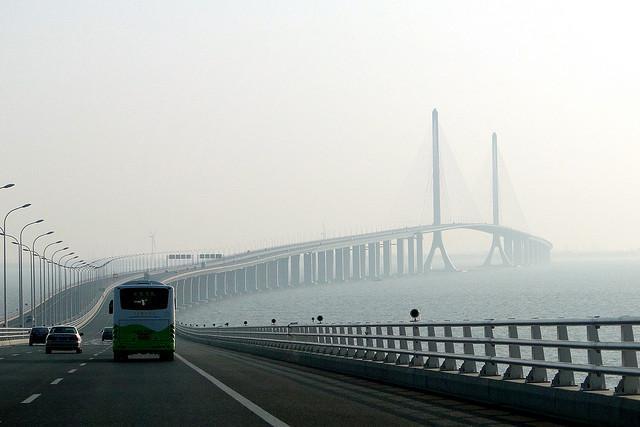How many trains are in the photo?
Give a very brief answer. 0. 